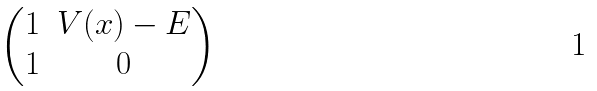<formula> <loc_0><loc_0><loc_500><loc_500>\begin{pmatrix} 1 & V ( x ) - E \\ 1 & 0 \end{pmatrix}</formula> 